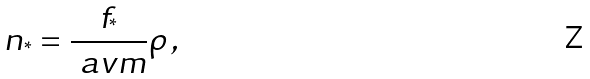Convert formula to latex. <formula><loc_0><loc_0><loc_500><loc_500>n _ { ^ { * } } = \frac { f _ { ^ { * } } } { \ a v m } \rho \, ,</formula> 